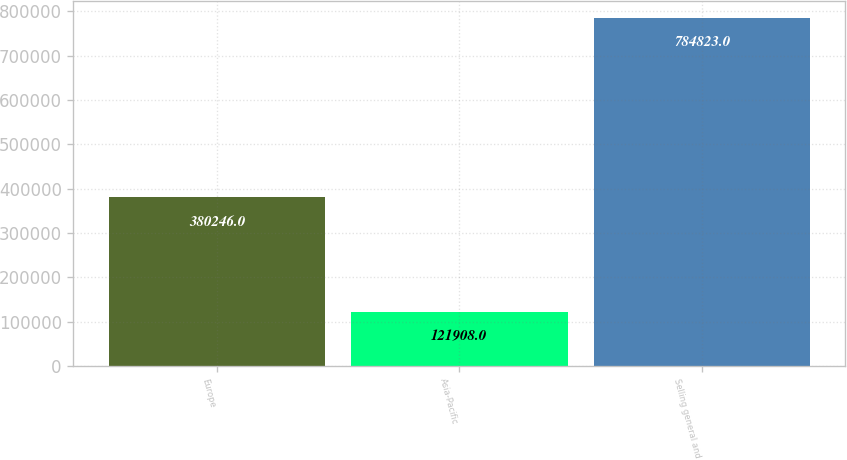<chart> <loc_0><loc_0><loc_500><loc_500><bar_chart><fcel>Europe<fcel>Asia-Pacific<fcel>Selling general and<nl><fcel>380246<fcel>121908<fcel>784823<nl></chart> 